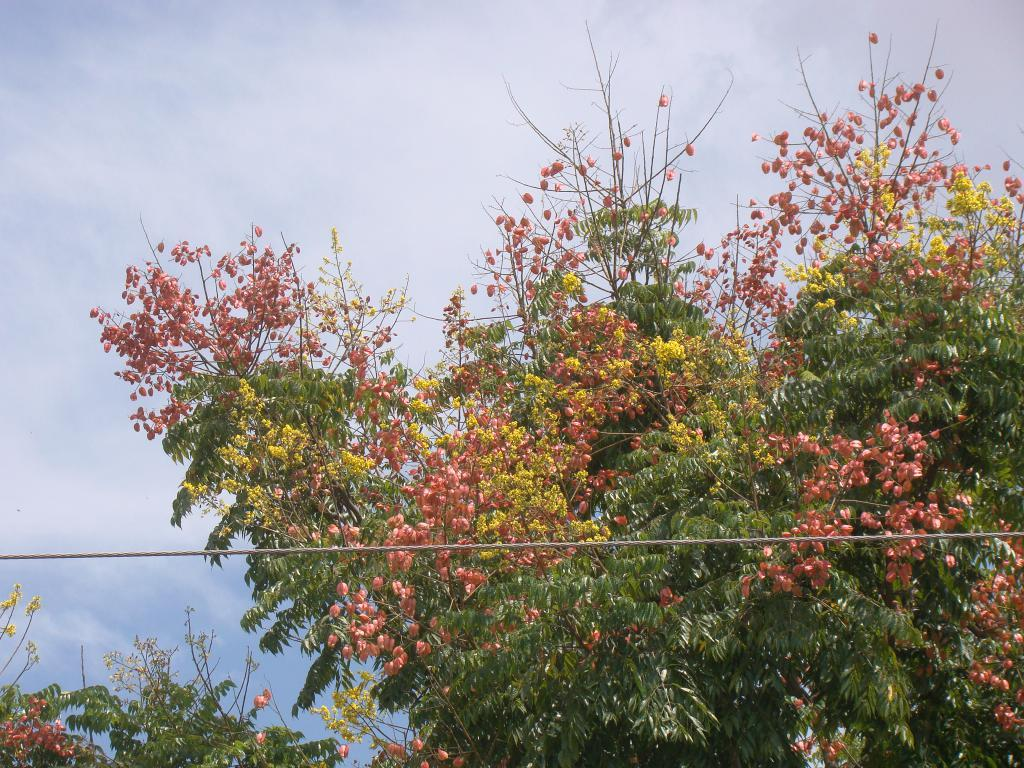What type of vegetation is present in the image? There are trees with green leaves in the image. What is located in front of the trees? There is a feeder in front of the trees. What can be seen in the background of the image? There are clouds in the background of the image. What color is the sky in the image? The sky is blue in the image. What type of crib is visible in the image? There is no crib present in the image. How many buckets are visible in the image? There are no buckets in the image. 